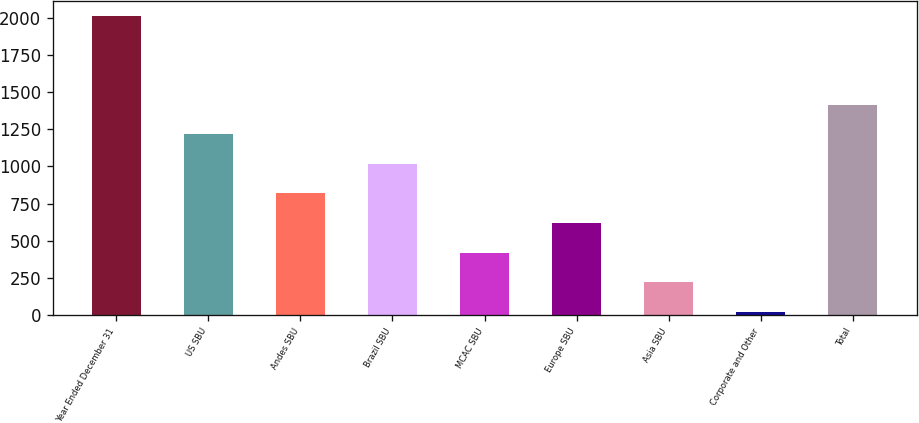Convert chart. <chart><loc_0><loc_0><loc_500><loc_500><bar_chart><fcel>Year Ended December 31<fcel>US SBU<fcel>Andes SBU<fcel>Brazil SBU<fcel>MCAC SBU<fcel>Europe SBU<fcel>Asia SBU<fcel>Corporate and Other<fcel>Total<nl><fcel>2013<fcel>1216.2<fcel>817.8<fcel>1017<fcel>419.4<fcel>618.6<fcel>220.2<fcel>21<fcel>1415.4<nl></chart> 